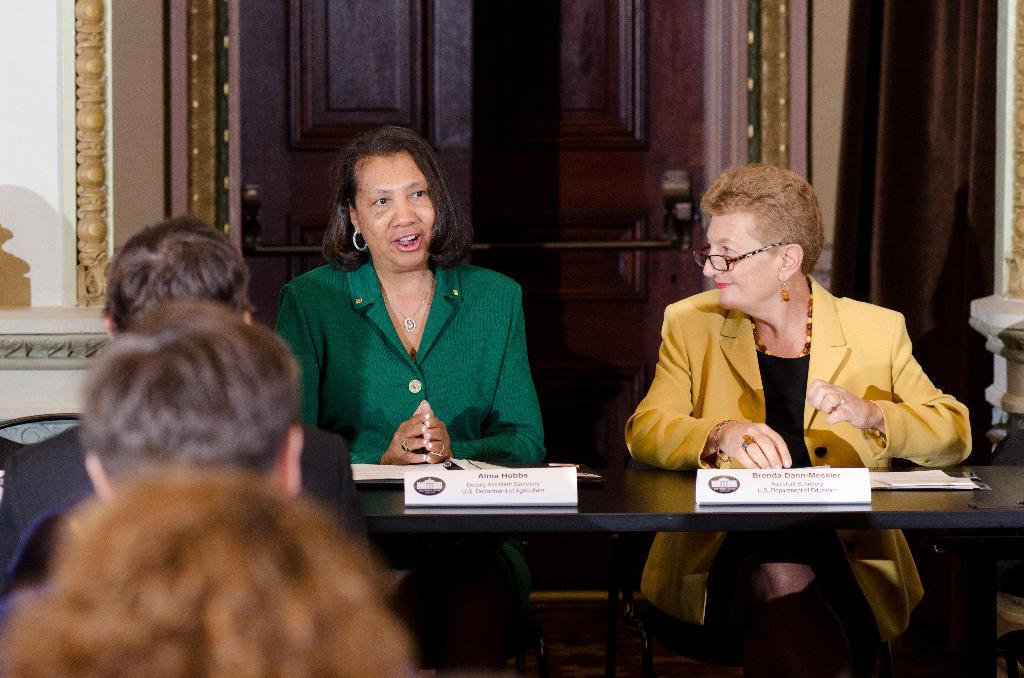What are the seated individuals doing in the image? There are people sitting on chairs in the image. What is happening in front of the seated individuals? There are people in front of the seated individuals. What are the people in front doing? The people in front are looking at the seated individuals. How many horses are visible in the frame of the image? There are no horses present in the image. 